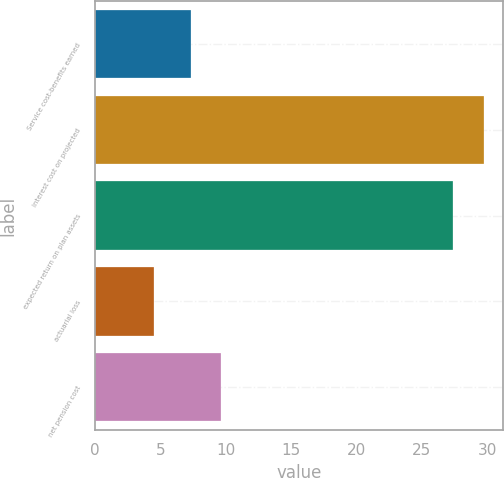Convert chart. <chart><loc_0><loc_0><loc_500><loc_500><bar_chart><fcel>Service cost-benefits earned<fcel>interest cost on projected<fcel>expected return on plan assets<fcel>actuarial loss<fcel>net pension cost<nl><fcel>7.3<fcel>29.72<fcel>27.4<fcel>4.5<fcel>9.62<nl></chart> 